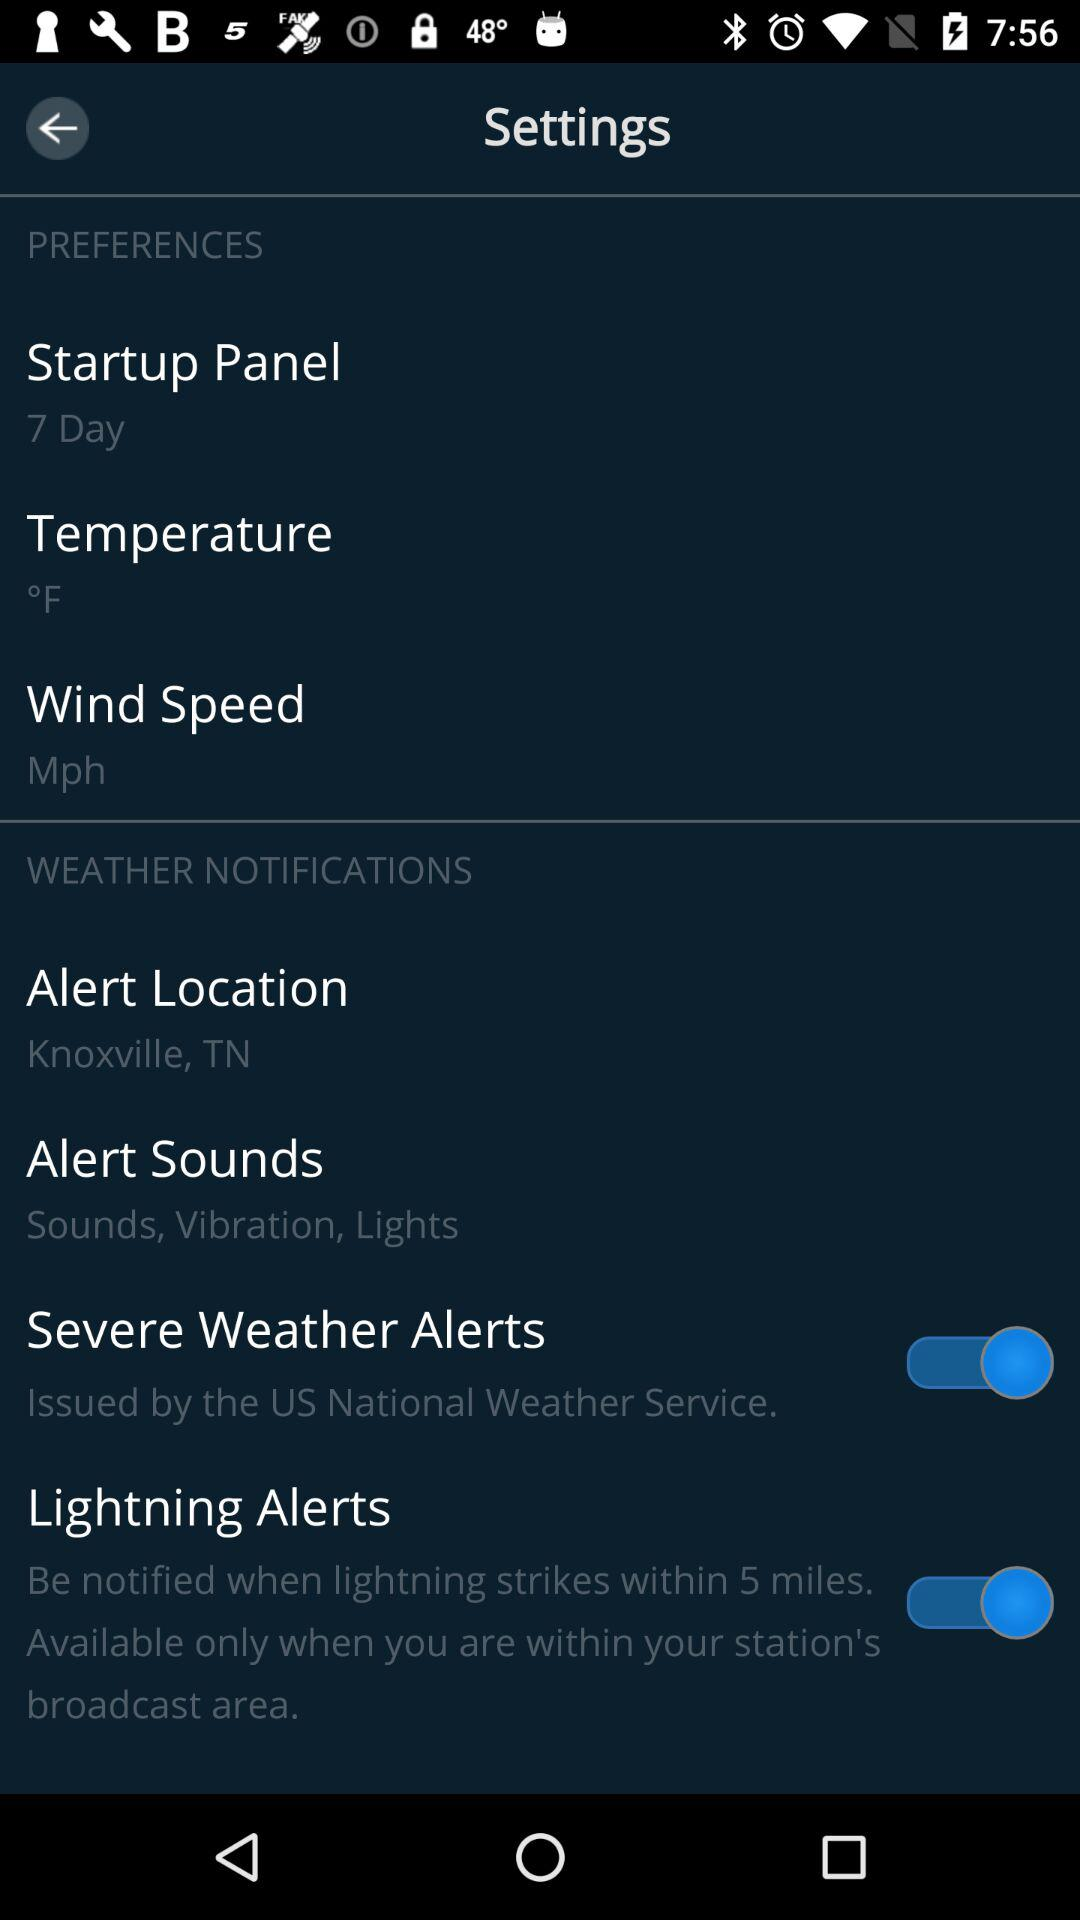How many items in the Weather Notifications section have a switch?
Answer the question using a single word or phrase. 2 